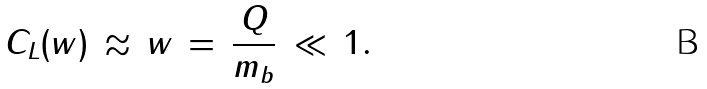<formula> <loc_0><loc_0><loc_500><loc_500>C _ { L } ( w ) \, \approx \, w \, = \, \frac { Q } { m _ { b } } \, \ll \, 1 .</formula> 